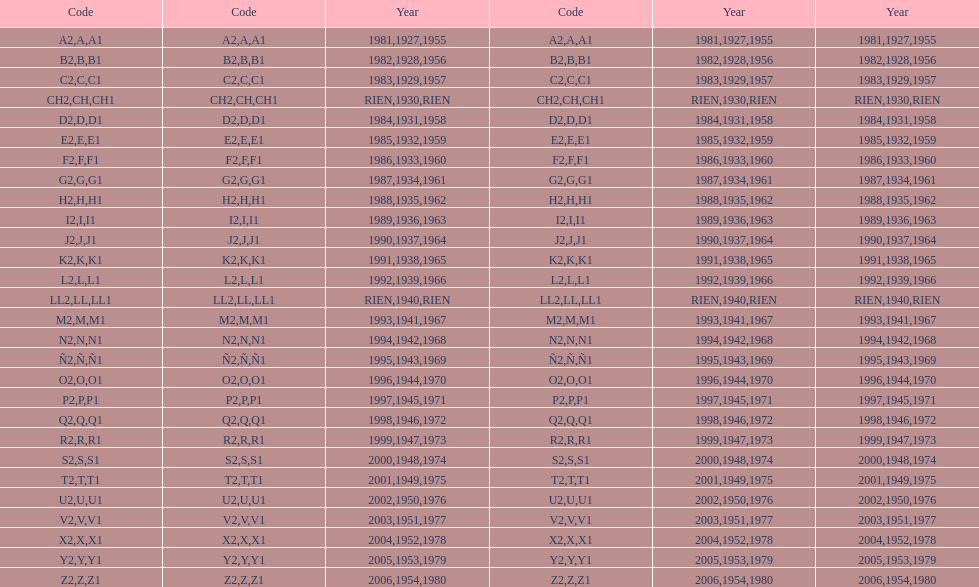Other than 1927 what year did the code start with a? 1955, 1981. 